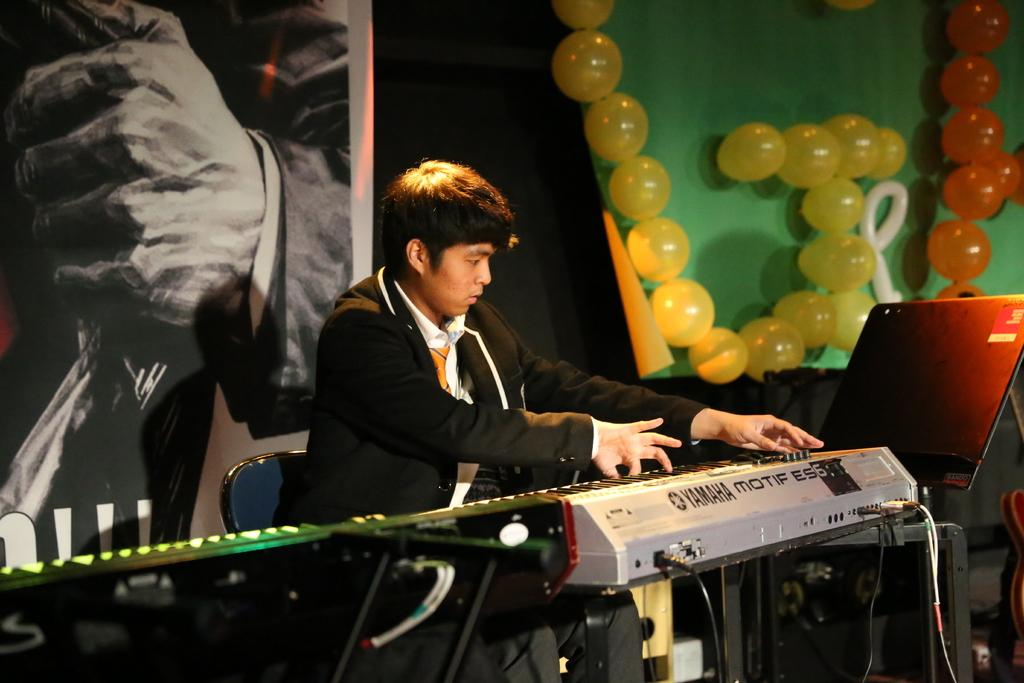Who is the main subject in the image? There is a boy in the image. What is the boy doing in the image? The boy is playing the piano. What can be seen on the background wall in the image? There is a painting and balloons on the background wall. What division of mathematics is the boy studying in the image? There is no indication in the image that the boy is studying any specific subject, let alone a division of mathematics. 